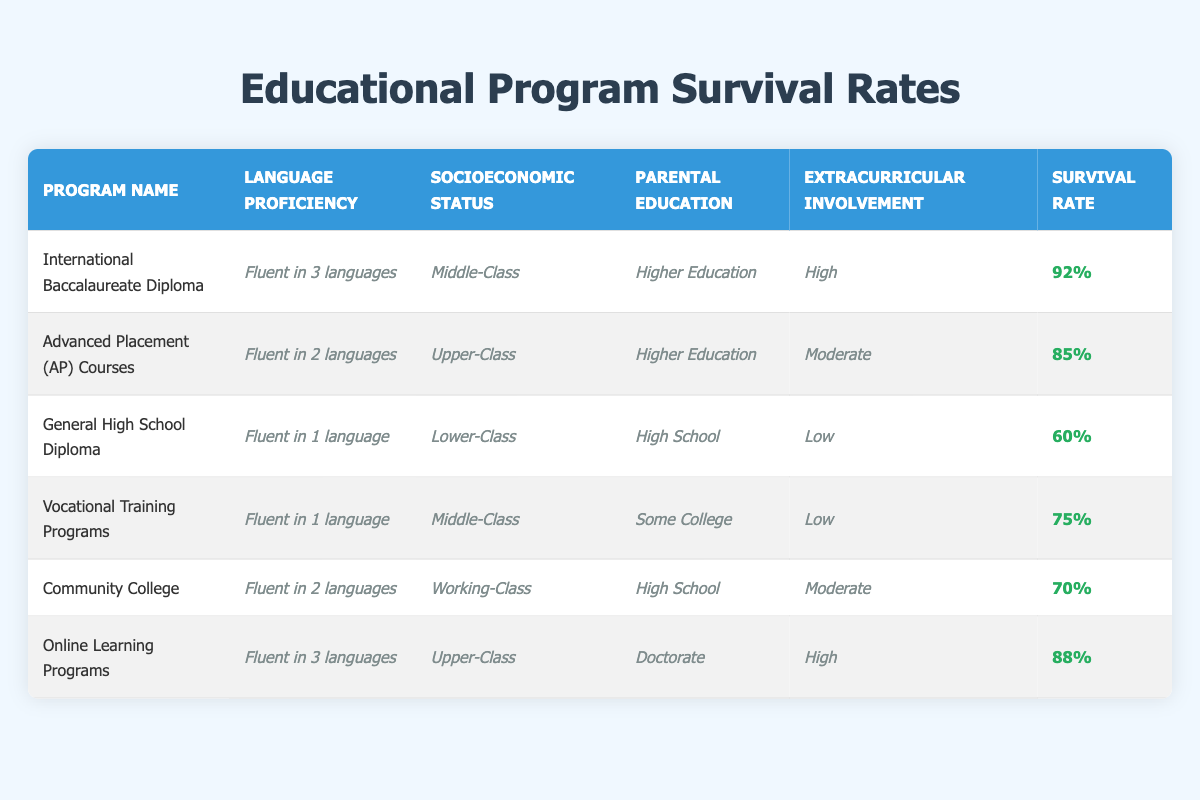What is the survival rate for the International Baccalaureate Diploma program? The table shows that the survival rate for the International Baccalaureate Diploma program is listed under the "Survival Rate" column, which indicates a value of 92%.
Answer: 92% Which program has the highest survival rate? By comparing the survival rates in the table, the International Baccalaureate Diploma program has the highest rate at 92%.
Answer: International Baccalaureate Diploma Is the socioeconomic status of students in the Community College program classified as Middle-Class? The table specifies the socioeconomic status of the Community College program as "Working-Class," which means the statement is false.
Answer: No What is the average survival rate for programs that involve fluency in 2 languages? The two programs that require fluency in 2 languages are Advanced Placement (AP) Courses (85%) and Community College (70%). The average is calculated as (85 + 70) / 2 = 77.5%.
Answer: 77.5% Do programs with higher parental education levels generally have higher survival rates? By analyzing the programs with different parental education levels, the International Baccalaureate Diploma and Advanced Placement programs, both with higher education, have rates above 80%. In contrast, the General High School Diploma, with only high school parental education, has a lower rate of 60%. Thus, it can be concluded that there is a correlation where higher parental education aligns with higher survival rates.
Answer: Yes How many programs have a survival rate lower than 75%? There are three programs with survival rates below 75%: General High School Diploma (60%), Vocational Training Programs (75%), and Community College (70%). The count of these programs is three.
Answer: 2 Which program has a socioeconomic status of Upper-Class and what is its survival rate? The Online Learning Programs are classified under Upper-Class socioeconomic status, and according to the table, their survival rate is 88%.
Answer: Online Learning Programs, 88% What is the difference in survival rates between the Vocational Training Programs and the General High School Diploma? The survival rate for Vocational Training Programs is 75%, while for General High School Diploma it is 60%. The difference is calculated as 75 - 60 = 15%.
Answer: 15% How many total programs have high extracurricular involvement? By examining the table, the programs with high extracurricular involvement are the International Baccalaureate Diploma and Online Learning Programs. That's a total of 2 programs.
Answer: 2 